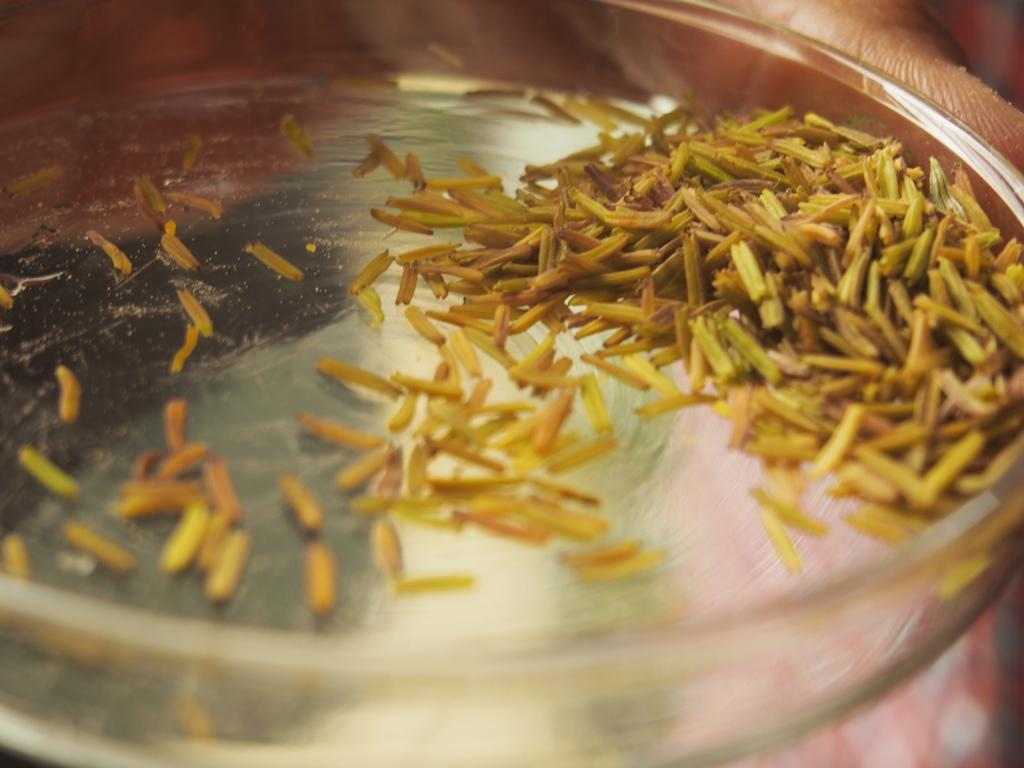What is the main subject of the image? There is food in a utensil in the image. Can you describe any other elements in the image? A person's hand is visible in the image. What is located at the bottom of the image? There is an object at the bottom of the image. What type of crown is the person wearing in the image? There is no crown present in the image; only food, a utensil, and a person's hand are visible. Can you describe the locket that the person is holding in the image? There is no locket present in the image; only food, a utensil, and a person's hand are visible. 